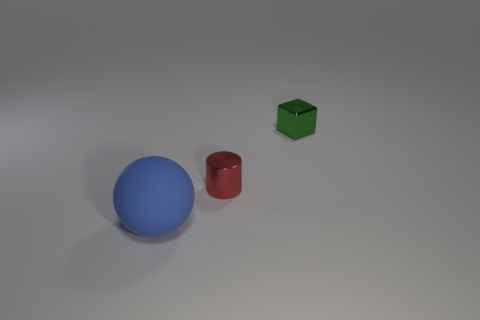Add 3 tiny yellow rubber objects. How many objects exist? 6 Subtract all cubes. How many objects are left? 2 Add 2 large cyan shiny cylinders. How many large cyan shiny cylinders exist? 2 Subtract 0 yellow balls. How many objects are left? 3 Subtract all large purple rubber balls. Subtract all tiny red metal cylinders. How many objects are left? 2 Add 2 small red cylinders. How many small red cylinders are left? 3 